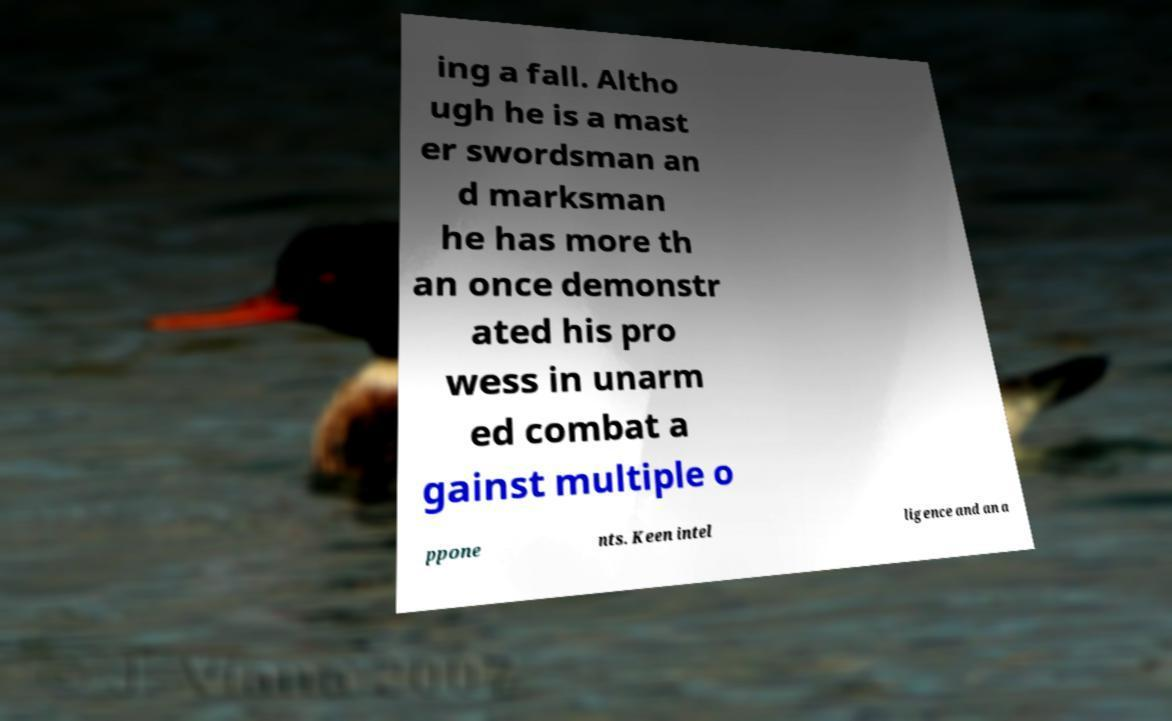Please identify and transcribe the text found in this image. ing a fall. Altho ugh he is a mast er swordsman an d marksman he has more th an once demonstr ated his pro wess in unarm ed combat a gainst multiple o ppone nts. Keen intel ligence and an a 